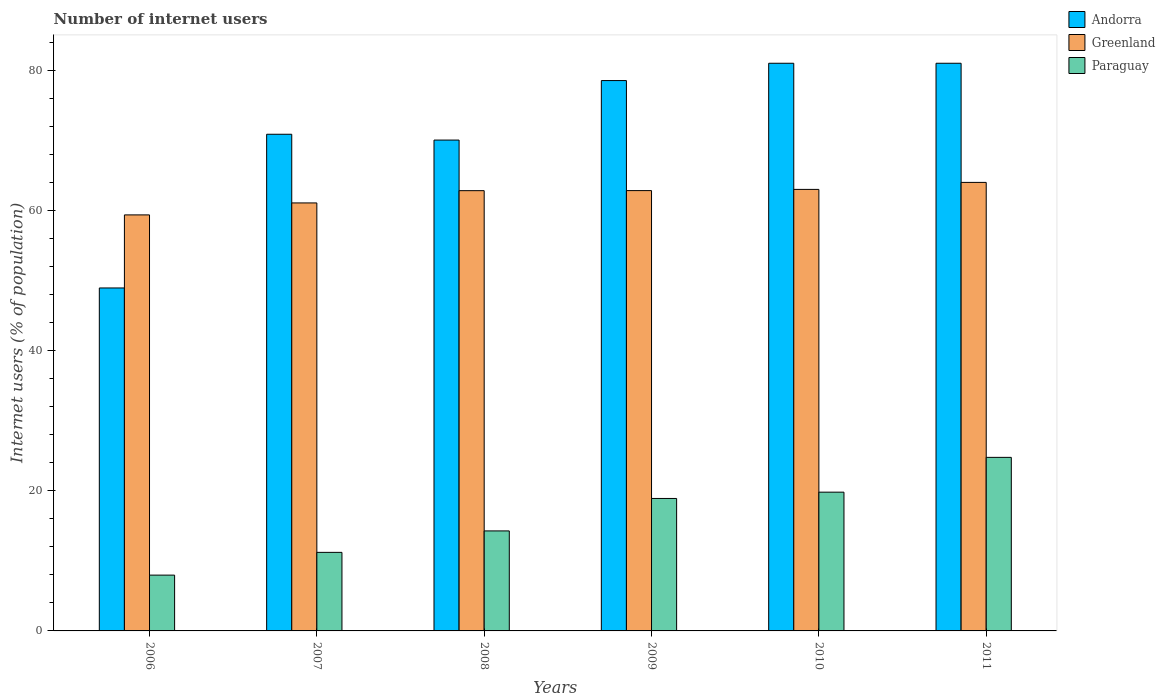How many different coloured bars are there?
Offer a very short reply. 3. How many groups of bars are there?
Provide a short and direct response. 6. Are the number of bars per tick equal to the number of legend labels?
Make the answer very short. Yes. Are the number of bars on each tick of the X-axis equal?
Offer a very short reply. Yes. How many bars are there on the 1st tick from the left?
Keep it short and to the point. 3. How many bars are there on the 3rd tick from the right?
Your response must be concise. 3. What is the label of the 4th group of bars from the left?
Your response must be concise. 2009. Across all years, what is the minimum number of internet users in Paraguay?
Make the answer very short. 7.96. What is the total number of internet users in Andorra in the graph?
Keep it short and to the point. 430.38. What is the difference between the number of internet users in Greenland in 2008 and that in 2010?
Your answer should be very brief. -0.18. What is the difference between the number of internet users in Andorra in 2007 and the number of internet users in Greenland in 2010?
Offer a terse response. 7.87. What is the average number of internet users in Andorra per year?
Provide a succinct answer. 71.73. In the year 2010, what is the difference between the number of internet users in Paraguay and number of internet users in Andorra?
Provide a short and direct response. -61.2. What is the ratio of the number of internet users in Paraguay in 2009 to that in 2010?
Keep it short and to the point. 0.95. What is the difference between the highest and the second highest number of internet users in Andorra?
Offer a very short reply. 0. What is the difference between the highest and the lowest number of internet users in Paraguay?
Provide a succinct answer. 16.8. Is the sum of the number of internet users in Paraguay in 2008 and 2011 greater than the maximum number of internet users in Andorra across all years?
Offer a terse response. No. What does the 1st bar from the left in 2007 represents?
Provide a short and direct response. Andorra. What does the 2nd bar from the right in 2009 represents?
Give a very brief answer. Greenland. Are all the bars in the graph horizontal?
Keep it short and to the point. No. What is the difference between two consecutive major ticks on the Y-axis?
Offer a very short reply. 20. Does the graph contain any zero values?
Your answer should be compact. No. Does the graph contain grids?
Offer a very short reply. No. Where does the legend appear in the graph?
Make the answer very short. Top right. How are the legend labels stacked?
Provide a succinct answer. Vertical. What is the title of the graph?
Ensure brevity in your answer.  Number of internet users. Does "Congo (Republic)" appear as one of the legend labels in the graph?
Your answer should be very brief. No. What is the label or title of the Y-axis?
Provide a succinct answer. Internet users (% of population). What is the Internet users (% of population) of Andorra in 2006?
Give a very brief answer. 48.94. What is the Internet users (% of population) of Greenland in 2006?
Offer a very short reply. 59.36. What is the Internet users (% of population) in Paraguay in 2006?
Give a very brief answer. 7.96. What is the Internet users (% of population) of Andorra in 2007?
Give a very brief answer. 70.87. What is the Internet users (% of population) of Greenland in 2007?
Make the answer very short. 61.07. What is the Internet users (% of population) of Paraguay in 2007?
Offer a very short reply. 11.21. What is the Internet users (% of population) of Andorra in 2008?
Provide a short and direct response. 70.04. What is the Internet users (% of population) of Greenland in 2008?
Your response must be concise. 62.82. What is the Internet users (% of population) of Paraguay in 2008?
Your answer should be compact. 14.27. What is the Internet users (% of population) in Andorra in 2009?
Your answer should be very brief. 78.53. What is the Internet users (% of population) in Greenland in 2009?
Offer a terse response. 62.83. What is the Internet users (% of population) in Paraguay in 2009?
Offer a very short reply. 18.9. What is the Internet users (% of population) in Greenland in 2010?
Provide a succinct answer. 63. What is the Internet users (% of population) in Paraguay in 2010?
Provide a short and direct response. 19.8. What is the Internet users (% of population) in Andorra in 2011?
Your answer should be very brief. 81. What is the Internet users (% of population) in Paraguay in 2011?
Make the answer very short. 24.76. Across all years, what is the maximum Internet users (% of population) of Andorra?
Give a very brief answer. 81. Across all years, what is the maximum Internet users (% of population) in Greenland?
Provide a succinct answer. 64. Across all years, what is the maximum Internet users (% of population) in Paraguay?
Keep it short and to the point. 24.76. Across all years, what is the minimum Internet users (% of population) of Andorra?
Your answer should be very brief. 48.94. Across all years, what is the minimum Internet users (% of population) of Greenland?
Ensure brevity in your answer.  59.36. Across all years, what is the minimum Internet users (% of population) of Paraguay?
Give a very brief answer. 7.96. What is the total Internet users (% of population) in Andorra in the graph?
Provide a short and direct response. 430.38. What is the total Internet users (% of population) in Greenland in the graph?
Provide a succinct answer. 373.08. What is the total Internet users (% of population) in Paraguay in the graph?
Offer a terse response. 96.91. What is the difference between the Internet users (% of population) in Andorra in 2006 and that in 2007?
Offer a terse response. -21.93. What is the difference between the Internet users (% of population) in Greenland in 2006 and that in 2007?
Make the answer very short. -1.71. What is the difference between the Internet users (% of population) of Paraguay in 2006 and that in 2007?
Your answer should be compact. -3.25. What is the difference between the Internet users (% of population) of Andorra in 2006 and that in 2008?
Provide a succinct answer. -21.1. What is the difference between the Internet users (% of population) in Greenland in 2006 and that in 2008?
Give a very brief answer. -3.46. What is the difference between the Internet users (% of population) in Paraguay in 2006 and that in 2008?
Offer a terse response. -6.31. What is the difference between the Internet users (% of population) of Andorra in 2006 and that in 2009?
Your answer should be very brief. -29.59. What is the difference between the Internet users (% of population) of Greenland in 2006 and that in 2009?
Your answer should be compact. -3.47. What is the difference between the Internet users (% of population) of Paraguay in 2006 and that in 2009?
Provide a short and direct response. -10.94. What is the difference between the Internet users (% of population) in Andorra in 2006 and that in 2010?
Ensure brevity in your answer.  -32.06. What is the difference between the Internet users (% of population) of Greenland in 2006 and that in 2010?
Provide a short and direct response. -3.64. What is the difference between the Internet users (% of population) in Paraguay in 2006 and that in 2010?
Your response must be concise. -11.84. What is the difference between the Internet users (% of population) in Andorra in 2006 and that in 2011?
Provide a short and direct response. -32.06. What is the difference between the Internet users (% of population) of Greenland in 2006 and that in 2011?
Offer a terse response. -4.64. What is the difference between the Internet users (% of population) of Paraguay in 2006 and that in 2011?
Your answer should be compact. -16.8. What is the difference between the Internet users (% of population) in Andorra in 2007 and that in 2008?
Make the answer very short. 0.83. What is the difference between the Internet users (% of population) of Greenland in 2007 and that in 2008?
Provide a short and direct response. -1.75. What is the difference between the Internet users (% of population) of Paraguay in 2007 and that in 2008?
Keep it short and to the point. -3.06. What is the difference between the Internet users (% of population) of Andorra in 2007 and that in 2009?
Keep it short and to the point. -7.66. What is the difference between the Internet users (% of population) of Greenland in 2007 and that in 2009?
Offer a very short reply. -1.76. What is the difference between the Internet users (% of population) in Paraguay in 2007 and that in 2009?
Make the answer very short. -7.69. What is the difference between the Internet users (% of population) in Andorra in 2007 and that in 2010?
Give a very brief answer. -10.13. What is the difference between the Internet users (% of population) of Greenland in 2007 and that in 2010?
Your response must be concise. -1.93. What is the difference between the Internet users (% of population) in Paraguay in 2007 and that in 2010?
Your answer should be compact. -8.59. What is the difference between the Internet users (% of population) in Andorra in 2007 and that in 2011?
Provide a succinct answer. -10.13. What is the difference between the Internet users (% of population) of Greenland in 2007 and that in 2011?
Offer a terse response. -2.93. What is the difference between the Internet users (% of population) of Paraguay in 2007 and that in 2011?
Provide a short and direct response. -13.55. What is the difference between the Internet users (% of population) in Andorra in 2008 and that in 2009?
Your answer should be very brief. -8.49. What is the difference between the Internet users (% of population) of Greenland in 2008 and that in 2009?
Offer a terse response. -0.01. What is the difference between the Internet users (% of population) in Paraguay in 2008 and that in 2009?
Keep it short and to the point. -4.63. What is the difference between the Internet users (% of population) of Andorra in 2008 and that in 2010?
Offer a very short reply. -10.96. What is the difference between the Internet users (% of population) of Greenland in 2008 and that in 2010?
Provide a short and direct response. -0.18. What is the difference between the Internet users (% of population) of Paraguay in 2008 and that in 2010?
Provide a succinct answer. -5.53. What is the difference between the Internet users (% of population) of Andorra in 2008 and that in 2011?
Offer a terse response. -10.96. What is the difference between the Internet users (% of population) of Greenland in 2008 and that in 2011?
Give a very brief answer. -1.18. What is the difference between the Internet users (% of population) of Paraguay in 2008 and that in 2011?
Your answer should be very brief. -10.49. What is the difference between the Internet users (% of population) of Andorra in 2009 and that in 2010?
Your answer should be compact. -2.47. What is the difference between the Internet users (% of population) in Greenland in 2009 and that in 2010?
Give a very brief answer. -0.17. What is the difference between the Internet users (% of population) of Paraguay in 2009 and that in 2010?
Keep it short and to the point. -0.9. What is the difference between the Internet users (% of population) in Andorra in 2009 and that in 2011?
Ensure brevity in your answer.  -2.47. What is the difference between the Internet users (% of population) of Greenland in 2009 and that in 2011?
Your answer should be compact. -1.17. What is the difference between the Internet users (% of population) of Paraguay in 2009 and that in 2011?
Give a very brief answer. -5.86. What is the difference between the Internet users (% of population) in Paraguay in 2010 and that in 2011?
Offer a terse response. -4.96. What is the difference between the Internet users (% of population) of Andorra in 2006 and the Internet users (% of population) of Greenland in 2007?
Your answer should be compact. -12.13. What is the difference between the Internet users (% of population) in Andorra in 2006 and the Internet users (% of population) in Paraguay in 2007?
Provide a succinct answer. 37.73. What is the difference between the Internet users (% of population) in Greenland in 2006 and the Internet users (% of population) in Paraguay in 2007?
Give a very brief answer. 48.15. What is the difference between the Internet users (% of population) in Andorra in 2006 and the Internet users (% of population) in Greenland in 2008?
Ensure brevity in your answer.  -13.88. What is the difference between the Internet users (% of population) in Andorra in 2006 and the Internet users (% of population) in Paraguay in 2008?
Offer a terse response. 34.67. What is the difference between the Internet users (% of population) of Greenland in 2006 and the Internet users (% of population) of Paraguay in 2008?
Offer a terse response. 45.09. What is the difference between the Internet users (% of population) of Andorra in 2006 and the Internet users (% of population) of Greenland in 2009?
Your response must be concise. -13.89. What is the difference between the Internet users (% of population) of Andorra in 2006 and the Internet users (% of population) of Paraguay in 2009?
Give a very brief answer. 30.04. What is the difference between the Internet users (% of population) in Greenland in 2006 and the Internet users (% of population) in Paraguay in 2009?
Provide a short and direct response. 40.46. What is the difference between the Internet users (% of population) of Andorra in 2006 and the Internet users (% of population) of Greenland in 2010?
Provide a short and direct response. -14.06. What is the difference between the Internet users (% of population) in Andorra in 2006 and the Internet users (% of population) in Paraguay in 2010?
Your answer should be very brief. 29.14. What is the difference between the Internet users (% of population) in Greenland in 2006 and the Internet users (% of population) in Paraguay in 2010?
Give a very brief answer. 39.56. What is the difference between the Internet users (% of population) in Andorra in 2006 and the Internet users (% of population) in Greenland in 2011?
Ensure brevity in your answer.  -15.06. What is the difference between the Internet users (% of population) of Andorra in 2006 and the Internet users (% of population) of Paraguay in 2011?
Offer a very short reply. 24.17. What is the difference between the Internet users (% of population) of Greenland in 2006 and the Internet users (% of population) of Paraguay in 2011?
Provide a succinct answer. 34.6. What is the difference between the Internet users (% of population) in Andorra in 2007 and the Internet users (% of population) in Greenland in 2008?
Give a very brief answer. 8.05. What is the difference between the Internet users (% of population) in Andorra in 2007 and the Internet users (% of population) in Paraguay in 2008?
Ensure brevity in your answer.  56.6. What is the difference between the Internet users (% of population) of Greenland in 2007 and the Internet users (% of population) of Paraguay in 2008?
Your answer should be very brief. 46.8. What is the difference between the Internet users (% of population) of Andorra in 2007 and the Internet users (% of population) of Greenland in 2009?
Offer a terse response. 8.04. What is the difference between the Internet users (% of population) of Andorra in 2007 and the Internet users (% of population) of Paraguay in 2009?
Offer a terse response. 51.97. What is the difference between the Internet users (% of population) of Greenland in 2007 and the Internet users (% of population) of Paraguay in 2009?
Provide a short and direct response. 42.17. What is the difference between the Internet users (% of population) in Andorra in 2007 and the Internet users (% of population) in Greenland in 2010?
Ensure brevity in your answer.  7.87. What is the difference between the Internet users (% of population) in Andorra in 2007 and the Internet users (% of population) in Paraguay in 2010?
Your answer should be compact. 51.07. What is the difference between the Internet users (% of population) of Greenland in 2007 and the Internet users (% of population) of Paraguay in 2010?
Offer a very short reply. 41.27. What is the difference between the Internet users (% of population) of Andorra in 2007 and the Internet users (% of population) of Greenland in 2011?
Your answer should be compact. 6.87. What is the difference between the Internet users (% of population) in Andorra in 2007 and the Internet users (% of population) in Paraguay in 2011?
Ensure brevity in your answer.  46.11. What is the difference between the Internet users (% of population) of Greenland in 2007 and the Internet users (% of population) of Paraguay in 2011?
Your answer should be very brief. 36.31. What is the difference between the Internet users (% of population) in Andorra in 2008 and the Internet users (% of population) in Greenland in 2009?
Your answer should be very brief. 7.21. What is the difference between the Internet users (% of population) of Andorra in 2008 and the Internet users (% of population) of Paraguay in 2009?
Make the answer very short. 51.14. What is the difference between the Internet users (% of population) in Greenland in 2008 and the Internet users (% of population) in Paraguay in 2009?
Your response must be concise. 43.92. What is the difference between the Internet users (% of population) of Andorra in 2008 and the Internet users (% of population) of Greenland in 2010?
Offer a terse response. 7.04. What is the difference between the Internet users (% of population) in Andorra in 2008 and the Internet users (% of population) in Paraguay in 2010?
Your answer should be compact. 50.24. What is the difference between the Internet users (% of population) in Greenland in 2008 and the Internet users (% of population) in Paraguay in 2010?
Make the answer very short. 43.02. What is the difference between the Internet users (% of population) of Andorra in 2008 and the Internet users (% of population) of Greenland in 2011?
Offer a very short reply. 6.04. What is the difference between the Internet users (% of population) of Andorra in 2008 and the Internet users (% of population) of Paraguay in 2011?
Give a very brief answer. 45.28. What is the difference between the Internet users (% of population) of Greenland in 2008 and the Internet users (% of population) of Paraguay in 2011?
Your answer should be compact. 38.06. What is the difference between the Internet users (% of population) of Andorra in 2009 and the Internet users (% of population) of Greenland in 2010?
Give a very brief answer. 15.53. What is the difference between the Internet users (% of population) of Andorra in 2009 and the Internet users (% of population) of Paraguay in 2010?
Offer a very short reply. 58.73. What is the difference between the Internet users (% of population) of Greenland in 2009 and the Internet users (% of population) of Paraguay in 2010?
Your answer should be very brief. 43.03. What is the difference between the Internet users (% of population) in Andorra in 2009 and the Internet users (% of population) in Greenland in 2011?
Offer a very short reply. 14.53. What is the difference between the Internet users (% of population) in Andorra in 2009 and the Internet users (% of population) in Paraguay in 2011?
Give a very brief answer. 53.77. What is the difference between the Internet users (% of population) in Greenland in 2009 and the Internet users (% of population) in Paraguay in 2011?
Your answer should be compact. 38.07. What is the difference between the Internet users (% of population) in Andorra in 2010 and the Internet users (% of population) in Greenland in 2011?
Provide a succinct answer. 17. What is the difference between the Internet users (% of population) of Andorra in 2010 and the Internet users (% of population) of Paraguay in 2011?
Ensure brevity in your answer.  56.24. What is the difference between the Internet users (% of population) in Greenland in 2010 and the Internet users (% of population) in Paraguay in 2011?
Offer a terse response. 38.24. What is the average Internet users (% of population) of Andorra per year?
Make the answer very short. 71.73. What is the average Internet users (% of population) of Greenland per year?
Your response must be concise. 62.18. What is the average Internet users (% of population) of Paraguay per year?
Keep it short and to the point. 16.15. In the year 2006, what is the difference between the Internet users (% of population) of Andorra and Internet users (% of population) of Greenland?
Your response must be concise. -10.42. In the year 2006, what is the difference between the Internet users (% of population) in Andorra and Internet users (% of population) in Paraguay?
Give a very brief answer. 40.97. In the year 2006, what is the difference between the Internet users (% of population) in Greenland and Internet users (% of population) in Paraguay?
Offer a terse response. 51.4. In the year 2007, what is the difference between the Internet users (% of population) in Andorra and Internet users (% of population) in Paraguay?
Give a very brief answer. 59.66. In the year 2007, what is the difference between the Internet users (% of population) in Greenland and Internet users (% of population) in Paraguay?
Offer a very short reply. 49.86. In the year 2008, what is the difference between the Internet users (% of population) in Andorra and Internet users (% of population) in Greenland?
Give a very brief answer. 7.22. In the year 2008, what is the difference between the Internet users (% of population) in Andorra and Internet users (% of population) in Paraguay?
Keep it short and to the point. 55.77. In the year 2008, what is the difference between the Internet users (% of population) in Greenland and Internet users (% of population) in Paraguay?
Make the answer very short. 48.55. In the year 2009, what is the difference between the Internet users (% of population) of Andorra and Internet users (% of population) of Paraguay?
Offer a very short reply. 59.63. In the year 2009, what is the difference between the Internet users (% of population) of Greenland and Internet users (% of population) of Paraguay?
Make the answer very short. 43.93. In the year 2010, what is the difference between the Internet users (% of population) of Andorra and Internet users (% of population) of Greenland?
Offer a very short reply. 18. In the year 2010, what is the difference between the Internet users (% of population) in Andorra and Internet users (% of population) in Paraguay?
Keep it short and to the point. 61.2. In the year 2010, what is the difference between the Internet users (% of population) of Greenland and Internet users (% of population) of Paraguay?
Provide a succinct answer. 43.2. In the year 2011, what is the difference between the Internet users (% of population) in Andorra and Internet users (% of population) in Paraguay?
Provide a short and direct response. 56.24. In the year 2011, what is the difference between the Internet users (% of population) in Greenland and Internet users (% of population) in Paraguay?
Provide a short and direct response. 39.24. What is the ratio of the Internet users (% of population) of Andorra in 2006 to that in 2007?
Provide a succinct answer. 0.69. What is the ratio of the Internet users (% of population) in Paraguay in 2006 to that in 2007?
Your answer should be compact. 0.71. What is the ratio of the Internet users (% of population) of Andorra in 2006 to that in 2008?
Your answer should be compact. 0.7. What is the ratio of the Internet users (% of population) of Greenland in 2006 to that in 2008?
Your response must be concise. 0.94. What is the ratio of the Internet users (% of population) of Paraguay in 2006 to that in 2008?
Give a very brief answer. 0.56. What is the ratio of the Internet users (% of population) of Andorra in 2006 to that in 2009?
Keep it short and to the point. 0.62. What is the ratio of the Internet users (% of population) in Greenland in 2006 to that in 2009?
Give a very brief answer. 0.94. What is the ratio of the Internet users (% of population) of Paraguay in 2006 to that in 2009?
Offer a very short reply. 0.42. What is the ratio of the Internet users (% of population) in Andorra in 2006 to that in 2010?
Provide a short and direct response. 0.6. What is the ratio of the Internet users (% of population) in Greenland in 2006 to that in 2010?
Offer a very short reply. 0.94. What is the ratio of the Internet users (% of population) of Paraguay in 2006 to that in 2010?
Offer a terse response. 0.4. What is the ratio of the Internet users (% of population) of Andorra in 2006 to that in 2011?
Provide a short and direct response. 0.6. What is the ratio of the Internet users (% of population) in Greenland in 2006 to that in 2011?
Offer a terse response. 0.93. What is the ratio of the Internet users (% of population) in Paraguay in 2006 to that in 2011?
Offer a terse response. 0.32. What is the ratio of the Internet users (% of population) in Andorra in 2007 to that in 2008?
Your answer should be compact. 1.01. What is the ratio of the Internet users (% of population) of Greenland in 2007 to that in 2008?
Your answer should be very brief. 0.97. What is the ratio of the Internet users (% of population) in Paraguay in 2007 to that in 2008?
Make the answer very short. 0.79. What is the ratio of the Internet users (% of population) of Andorra in 2007 to that in 2009?
Your answer should be very brief. 0.9. What is the ratio of the Internet users (% of population) in Greenland in 2007 to that in 2009?
Your answer should be compact. 0.97. What is the ratio of the Internet users (% of population) in Paraguay in 2007 to that in 2009?
Give a very brief answer. 0.59. What is the ratio of the Internet users (% of population) of Andorra in 2007 to that in 2010?
Make the answer very short. 0.87. What is the ratio of the Internet users (% of population) in Greenland in 2007 to that in 2010?
Provide a succinct answer. 0.97. What is the ratio of the Internet users (% of population) of Paraguay in 2007 to that in 2010?
Provide a short and direct response. 0.57. What is the ratio of the Internet users (% of population) of Andorra in 2007 to that in 2011?
Your answer should be very brief. 0.87. What is the ratio of the Internet users (% of population) in Greenland in 2007 to that in 2011?
Give a very brief answer. 0.95. What is the ratio of the Internet users (% of population) in Paraguay in 2007 to that in 2011?
Your response must be concise. 0.45. What is the ratio of the Internet users (% of population) in Andorra in 2008 to that in 2009?
Offer a terse response. 0.89. What is the ratio of the Internet users (% of population) of Greenland in 2008 to that in 2009?
Offer a very short reply. 1. What is the ratio of the Internet users (% of population) of Paraguay in 2008 to that in 2009?
Your response must be concise. 0.76. What is the ratio of the Internet users (% of population) of Andorra in 2008 to that in 2010?
Ensure brevity in your answer.  0.86. What is the ratio of the Internet users (% of population) in Paraguay in 2008 to that in 2010?
Provide a short and direct response. 0.72. What is the ratio of the Internet users (% of population) in Andorra in 2008 to that in 2011?
Ensure brevity in your answer.  0.86. What is the ratio of the Internet users (% of population) of Greenland in 2008 to that in 2011?
Give a very brief answer. 0.98. What is the ratio of the Internet users (% of population) of Paraguay in 2008 to that in 2011?
Ensure brevity in your answer.  0.58. What is the ratio of the Internet users (% of population) in Andorra in 2009 to that in 2010?
Provide a succinct answer. 0.97. What is the ratio of the Internet users (% of population) in Paraguay in 2009 to that in 2010?
Make the answer very short. 0.95. What is the ratio of the Internet users (% of population) in Andorra in 2009 to that in 2011?
Make the answer very short. 0.97. What is the ratio of the Internet users (% of population) of Greenland in 2009 to that in 2011?
Provide a succinct answer. 0.98. What is the ratio of the Internet users (% of population) of Paraguay in 2009 to that in 2011?
Provide a short and direct response. 0.76. What is the ratio of the Internet users (% of population) of Greenland in 2010 to that in 2011?
Keep it short and to the point. 0.98. What is the ratio of the Internet users (% of population) in Paraguay in 2010 to that in 2011?
Your answer should be compact. 0.8. What is the difference between the highest and the second highest Internet users (% of population) in Greenland?
Your response must be concise. 1. What is the difference between the highest and the second highest Internet users (% of population) of Paraguay?
Give a very brief answer. 4.96. What is the difference between the highest and the lowest Internet users (% of population) in Andorra?
Offer a very short reply. 32.06. What is the difference between the highest and the lowest Internet users (% of population) of Greenland?
Keep it short and to the point. 4.64. What is the difference between the highest and the lowest Internet users (% of population) in Paraguay?
Provide a succinct answer. 16.8. 